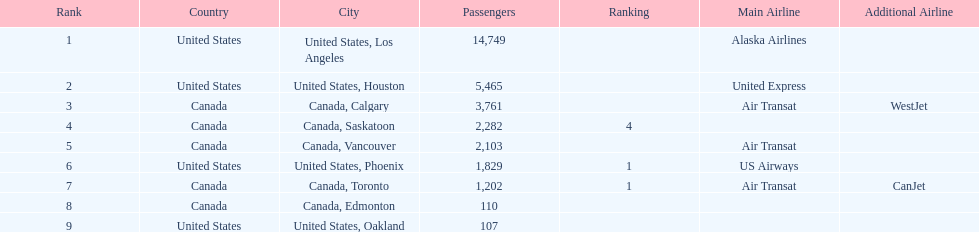How many cities from canada are on this list? 5. Give me the full table as a dictionary. {'header': ['Rank', 'Country', 'City', 'Passengers', 'Ranking', 'Main Airline', 'Additional Airline'], 'rows': [['1', 'United States', 'United States, Los Angeles', '14,749', '', 'Alaska Airlines', ''], ['2', 'United States', 'United States, Houston', '5,465', '', 'United Express', ''], ['3', 'Canada', 'Canada, Calgary', '3,761', '', 'Air Transat', 'WestJet'], ['4', 'Canada', 'Canada, Saskatoon', '2,282', '4', '', ''], ['5', 'Canada', 'Canada, Vancouver', '2,103', '', 'Air Transat', ''], ['6', 'United States', 'United States, Phoenix', '1,829', '1', 'US Airways', ''], ['7', 'Canada', 'Canada, Toronto', '1,202', '1', 'Air Transat', 'CanJet'], ['8', 'Canada', 'Canada, Edmonton', '110', '', '', ''], ['9', 'United States', 'United States, Oakland', '107', '', '', '']]} 